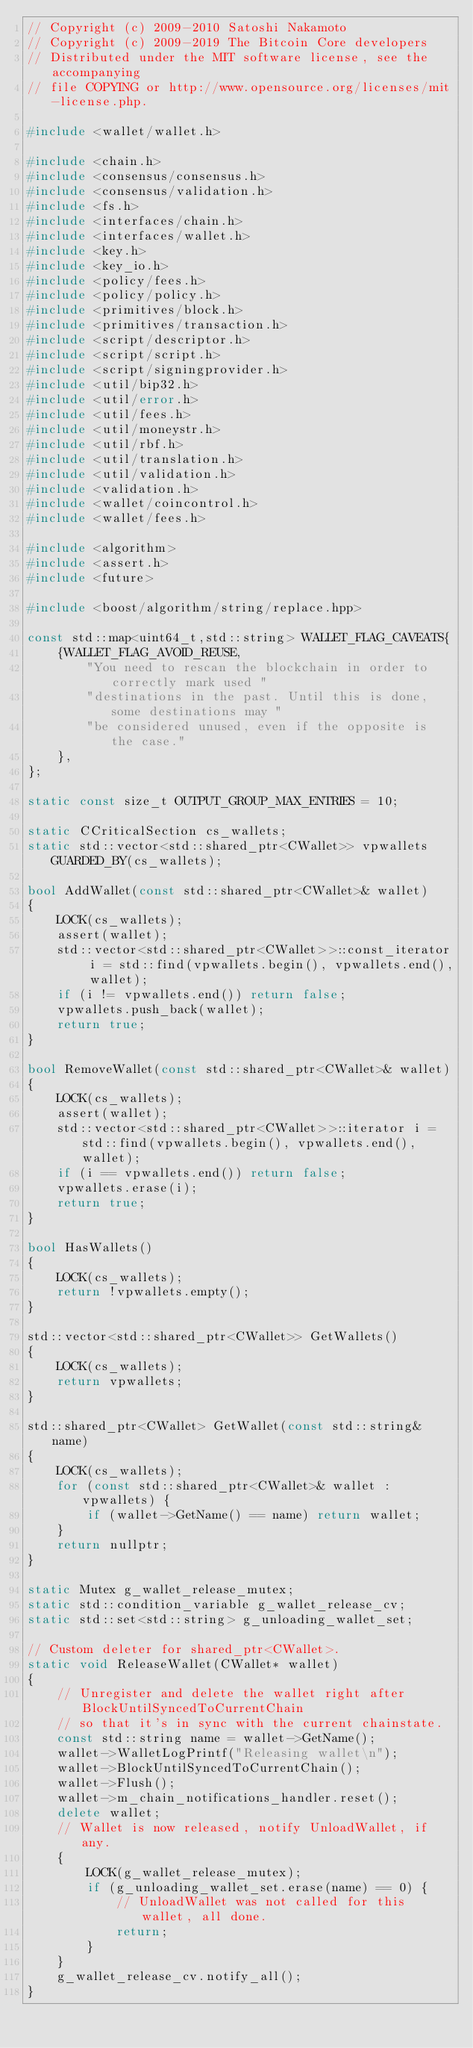Convert code to text. <code><loc_0><loc_0><loc_500><loc_500><_C++_>// Copyright (c) 2009-2010 Satoshi Nakamoto
// Copyright (c) 2009-2019 The Bitcoin Core developers
// Distributed under the MIT software license, see the accompanying
// file COPYING or http://www.opensource.org/licenses/mit-license.php.

#include <wallet/wallet.h>

#include <chain.h>
#include <consensus/consensus.h>
#include <consensus/validation.h>
#include <fs.h>
#include <interfaces/chain.h>
#include <interfaces/wallet.h>
#include <key.h>
#include <key_io.h>
#include <policy/fees.h>
#include <policy/policy.h>
#include <primitives/block.h>
#include <primitives/transaction.h>
#include <script/descriptor.h>
#include <script/script.h>
#include <script/signingprovider.h>
#include <util/bip32.h>
#include <util/error.h>
#include <util/fees.h>
#include <util/moneystr.h>
#include <util/rbf.h>
#include <util/translation.h>
#include <util/validation.h>
#include <validation.h>
#include <wallet/coincontrol.h>
#include <wallet/fees.h>

#include <algorithm>
#include <assert.h>
#include <future>

#include <boost/algorithm/string/replace.hpp>

const std::map<uint64_t,std::string> WALLET_FLAG_CAVEATS{
    {WALLET_FLAG_AVOID_REUSE,
        "You need to rescan the blockchain in order to correctly mark used "
        "destinations in the past. Until this is done, some destinations may "
        "be considered unused, even if the opposite is the case."
    },
};

static const size_t OUTPUT_GROUP_MAX_ENTRIES = 10;

static CCriticalSection cs_wallets;
static std::vector<std::shared_ptr<CWallet>> vpwallets GUARDED_BY(cs_wallets);

bool AddWallet(const std::shared_ptr<CWallet>& wallet)
{
    LOCK(cs_wallets);
    assert(wallet);
    std::vector<std::shared_ptr<CWallet>>::const_iterator i = std::find(vpwallets.begin(), vpwallets.end(), wallet);
    if (i != vpwallets.end()) return false;
    vpwallets.push_back(wallet);
    return true;
}

bool RemoveWallet(const std::shared_ptr<CWallet>& wallet)
{
    LOCK(cs_wallets);
    assert(wallet);
    std::vector<std::shared_ptr<CWallet>>::iterator i = std::find(vpwallets.begin(), vpwallets.end(), wallet);
    if (i == vpwallets.end()) return false;
    vpwallets.erase(i);
    return true;
}

bool HasWallets()
{
    LOCK(cs_wallets);
    return !vpwallets.empty();
}

std::vector<std::shared_ptr<CWallet>> GetWallets()
{
    LOCK(cs_wallets);
    return vpwallets;
}

std::shared_ptr<CWallet> GetWallet(const std::string& name)
{
    LOCK(cs_wallets);
    for (const std::shared_ptr<CWallet>& wallet : vpwallets) {
        if (wallet->GetName() == name) return wallet;
    }
    return nullptr;
}

static Mutex g_wallet_release_mutex;
static std::condition_variable g_wallet_release_cv;
static std::set<std::string> g_unloading_wallet_set;

// Custom deleter for shared_ptr<CWallet>.
static void ReleaseWallet(CWallet* wallet)
{
    // Unregister and delete the wallet right after BlockUntilSyncedToCurrentChain
    // so that it's in sync with the current chainstate.
    const std::string name = wallet->GetName();
    wallet->WalletLogPrintf("Releasing wallet\n");
    wallet->BlockUntilSyncedToCurrentChain();
    wallet->Flush();
    wallet->m_chain_notifications_handler.reset();
    delete wallet;
    // Wallet is now released, notify UnloadWallet, if any.
    {
        LOCK(g_wallet_release_mutex);
        if (g_unloading_wallet_set.erase(name) == 0) {
            // UnloadWallet was not called for this wallet, all done.
            return;
        }
    }
    g_wallet_release_cv.notify_all();
}
</code> 